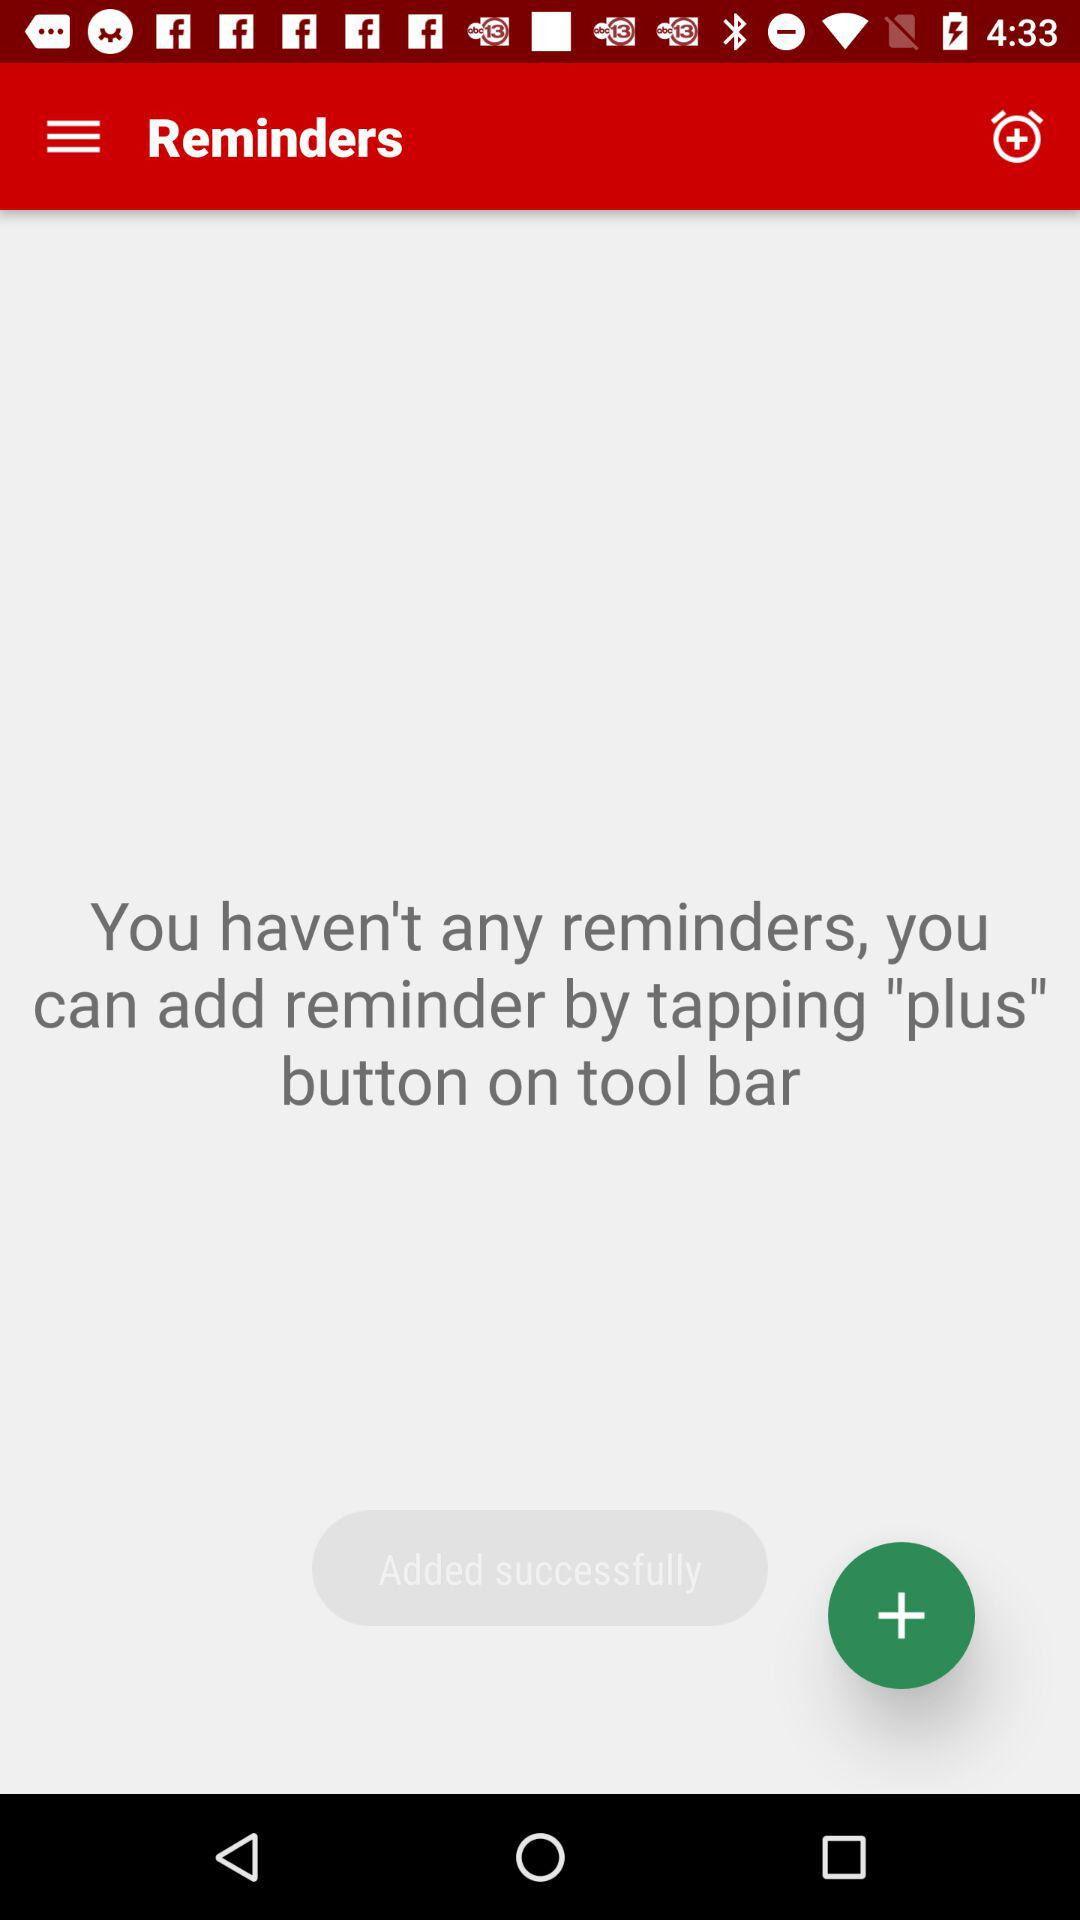How many reminders are there? There are no reminders. 